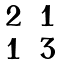Convert formula to latex. <formula><loc_0><loc_0><loc_500><loc_500>\begin{matrix} 2 & 1 \\ 1 & 3 \end{matrix}</formula> 